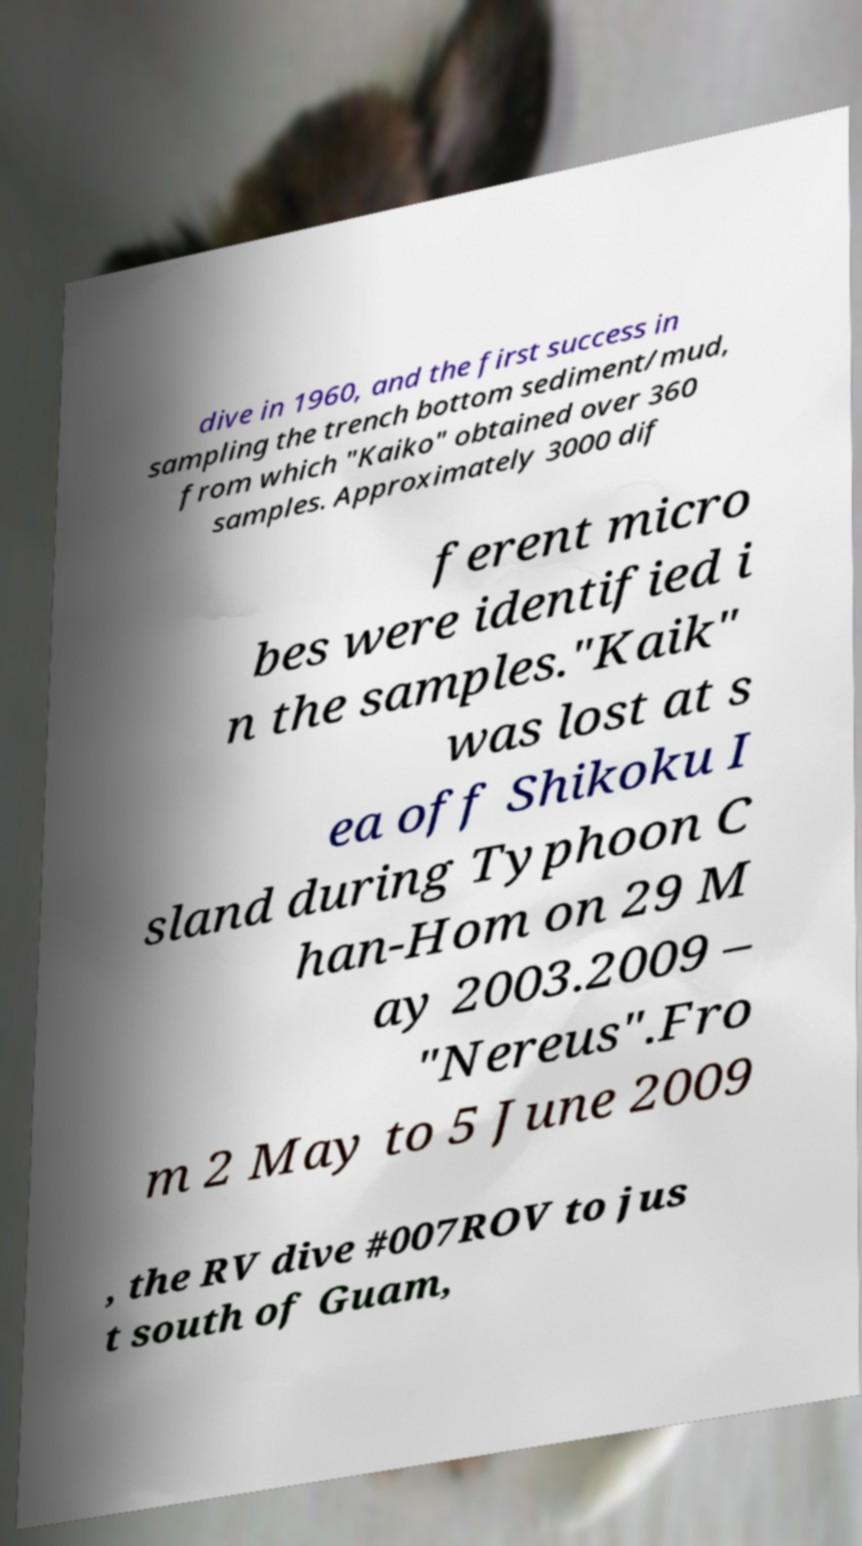Could you extract and type out the text from this image? dive in 1960, and the first success in sampling the trench bottom sediment/mud, from which "Kaiko" obtained over 360 samples. Approximately 3000 dif ferent micro bes were identified i n the samples."Kaik" was lost at s ea off Shikoku I sland during Typhoon C han-Hom on 29 M ay 2003.2009 – "Nereus".Fro m 2 May to 5 June 2009 , the RV dive #007ROV to jus t south of Guam, 